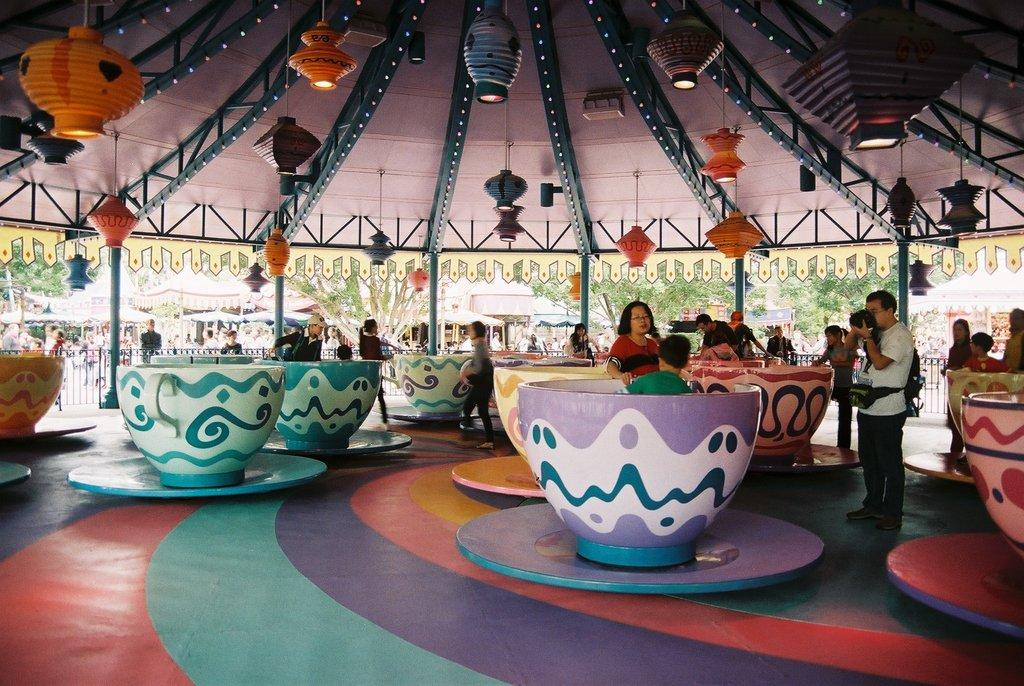What type of mechanical ride is in the image? There is a mechanical ride called "cup and saucer" in the image. What are the main components of the ride? The ride consists of cups and saucers. Can you describe the people in the image? There is a group of people in the image. What type of decorations are present in the image? Paper lanterns are present in the image. What can be seen in terms of lighting in the image? Lights are visible in the image. What type of establishments can be seen in the image? There are stalls in the image. What type of natural elements are present in the image? Trees are present in the image. What type of baseball equipment can be seen in the image? There is no baseball equipment present in the image. Can you describe the person who is offering the mechanical ride? There is no person specifically offering the ride in the image; it is a group of people enjoying the ride. 